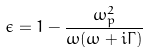<formula> <loc_0><loc_0><loc_500><loc_500>\epsilon = 1 - \frac { \omega _ { p } ^ { 2 } } { \omega ( \omega + i \Gamma ) }</formula> 